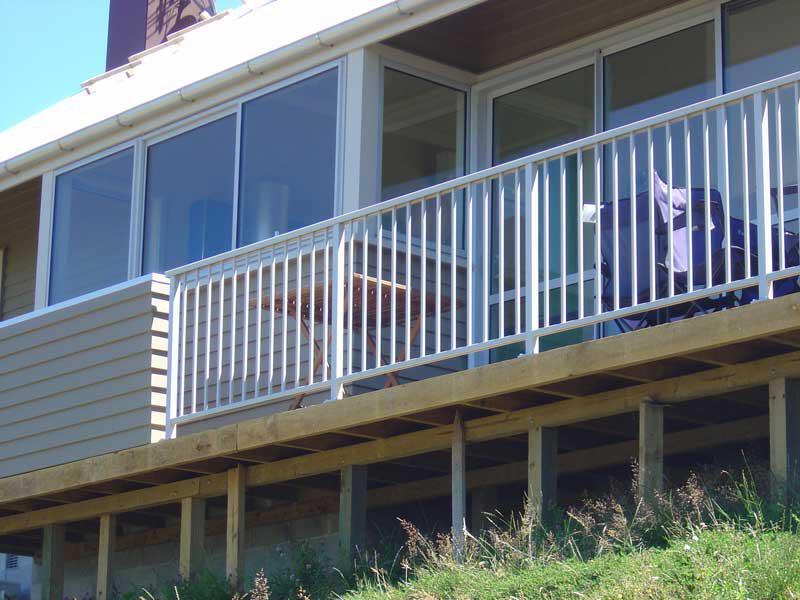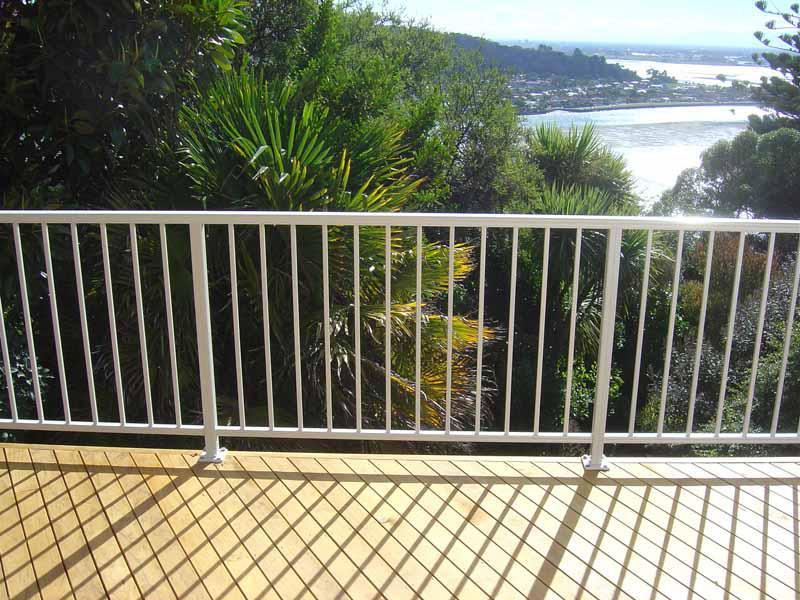The first image is the image on the left, the second image is the image on the right. For the images displayed, is the sentence "A balcony has a glass fence in one of the images." factually correct? Answer yes or no. No. The first image is the image on the left, the second image is the image on the right. Considering the images on both sides, is "There is a glass railing." valid? Answer yes or no. No. 